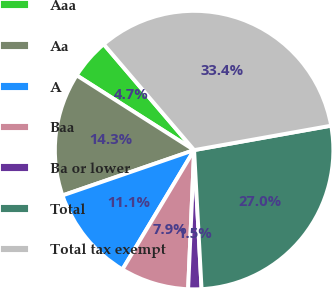Convert chart. <chart><loc_0><loc_0><loc_500><loc_500><pie_chart><fcel>Aaa<fcel>Aa<fcel>A<fcel>Baa<fcel>Ba or lower<fcel>Total<fcel>Total tax exempt<nl><fcel>4.73%<fcel>14.3%<fcel>11.11%<fcel>7.92%<fcel>1.54%<fcel>26.95%<fcel>33.44%<nl></chart> 